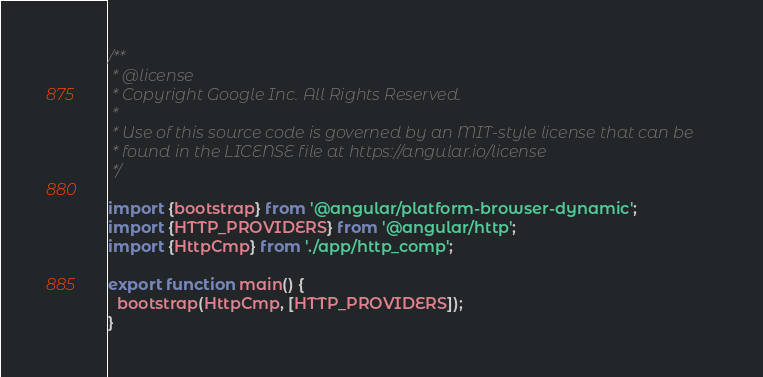<code> <loc_0><loc_0><loc_500><loc_500><_TypeScript_>/**
 * @license
 * Copyright Google Inc. All Rights Reserved.
 *
 * Use of this source code is governed by an MIT-style license that can be
 * found in the LICENSE file at https://angular.io/license
 */

import {bootstrap} from '@angular/platform-browser-dynamic';
import {HTTP_PROVIDERS} from '@angular/http';
import {HttpCmp} from './app/http_comp';

export function main() {
  bootstrap(HttpCmp, [HTTP_PROVIDERS]);
}
</code> 